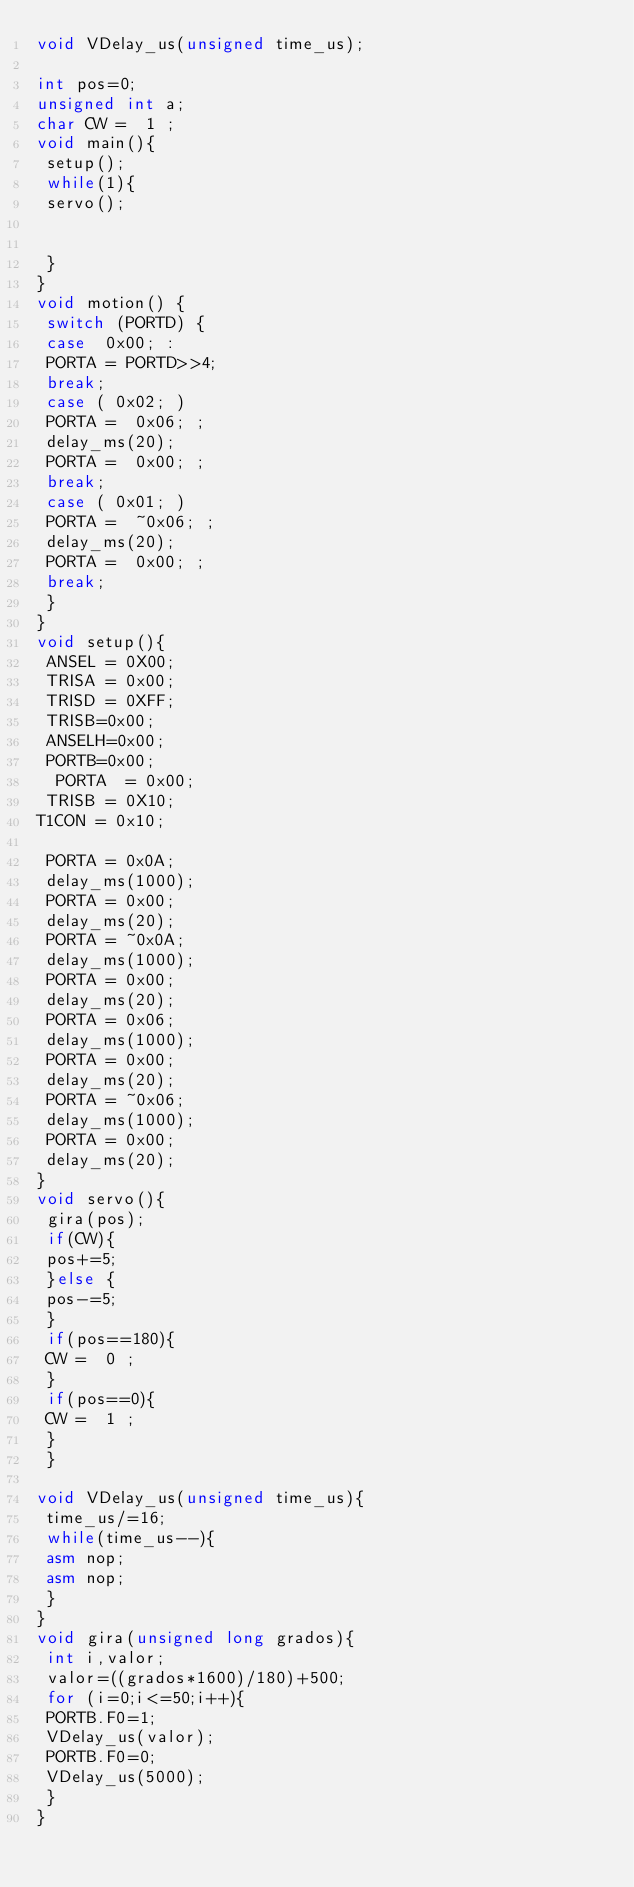Convert code to text. <code><loc_0><loc_0><loc_500><loc_500><_C++_>void VDelay_us(unsigned time_us);

int pos=0;
unsigned int a;
char CW =  1 ;
void main(){
 setup();
 while(1){
 servo();


 }
}
void motion() {
 switch (PORTD) {
 case  0x00; :
 PORTA = PORTD>>4;
 break;
 case ( 0x02; )
 PORTA =  0x06; ;
 delay_ms(20);
 PORTA =  0x00; ;
 break;
 case ( 0x01; )
 PORTA =  ~0x06; ;
 delay_ms(20);
 PORTA =  0x00; ;
 break;
 }
}
void setup(){
 ANSEL = 0X00;
 TRISA = 0x00;
 TRISD = 0XFF;
 TRISB=0x00;
 ANSELH=0x00;
 PORTB=0x00;
  PORTA  = 0x00;
 TRISB = 0X10;
T1CON = 0x10;

 PORTA = 0x0A;
 delay_ms(1000);
 PORTA = 0x00;
 delay_ms(20);
 PORTA = ~0x0A;
 delay_ms(1000);
 PORTA = 0x00;
 delay_ms(20);
 PORTA = 0x06;
 delay_ms(1000);
 PORTA = 0x00;
 delay_ms(20);
 PORTA = ~0x06;
 delay_ms(1000);
 PORTA = 0x00;
 delay_ms(20);
}
void servo(){
 gira(pos);
 if(CW){
 pos+=5;
 }else {
 pos-=5;
 }
 if(pos==180){
 CW =  0 ;
 }
 if(pos==0){
 CW =  1 ;
 }
 }

void VDelay_us(unsigned time_us){
 time_us/=16;
 while(time_us--){
 asm nop;
 asm nop;
 }
}
void gira(unsigned long grados){
 int i,valor;
 valor=((grados*1600)/180)+500;
 for (i=0;i<=50;i++){
 PORTB.F0=1;
 VDelay_us(valor);
 PORTB.F0=0;
 VDelay_us(5000);
 }
}
</code> 